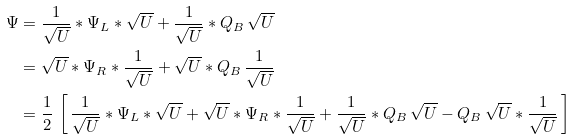Convert formula to latex. <formula><loc_0><loc_0><loc_500><loc_500>\Psi & = \frac { 1 } { \sqrt { U } } \ast \Psi _ { L } \ast \sqrt { U } + \frac { 1 } { \sqrt { U } } \ast Q _ { B } \, \sqrt { U } \\ & = \sqrt { U } \ast \Psi _ { R } \ast \frac { 1 } { \sqrt { U } } + \sqrt { U } \ast Q _ { B } \, \frac { 1 } { \sqrt { U } } \\ & = \frac { 1 } { 2 } \, \left [ \, \frac { 1 } { \sqrt { U } } \ast \Psi _ { L } \ast \sqrt { U } + \sqrt { U } \ast \Psi _ { R } \ast \frac { 1 } { \sqrt { U } } + \frac { 1 } { \sqrt { U } } \ast Q _ { B } \, \sqrt { U } - Q _ { B } \, \sqrt { U } \ast \frac { 1 } { \sqrt { U } } \, \right ]</formula> 